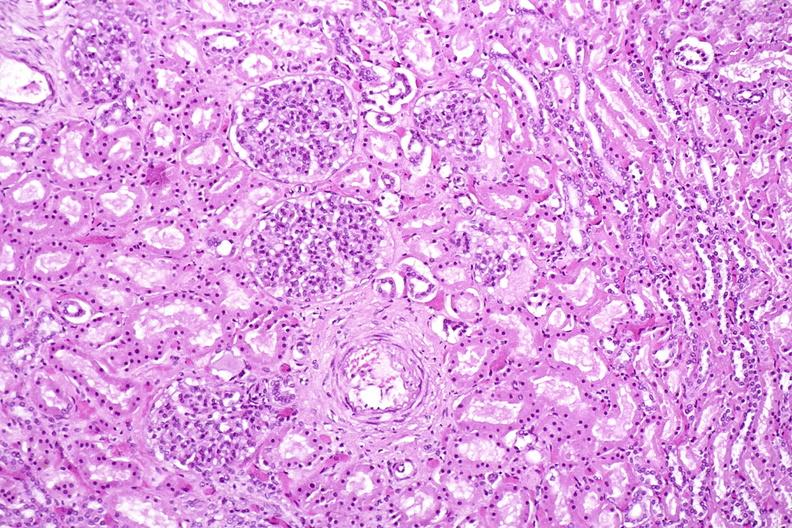does this image show kidney, normal histology?
Answer the question using a single word or phrase. Yes 